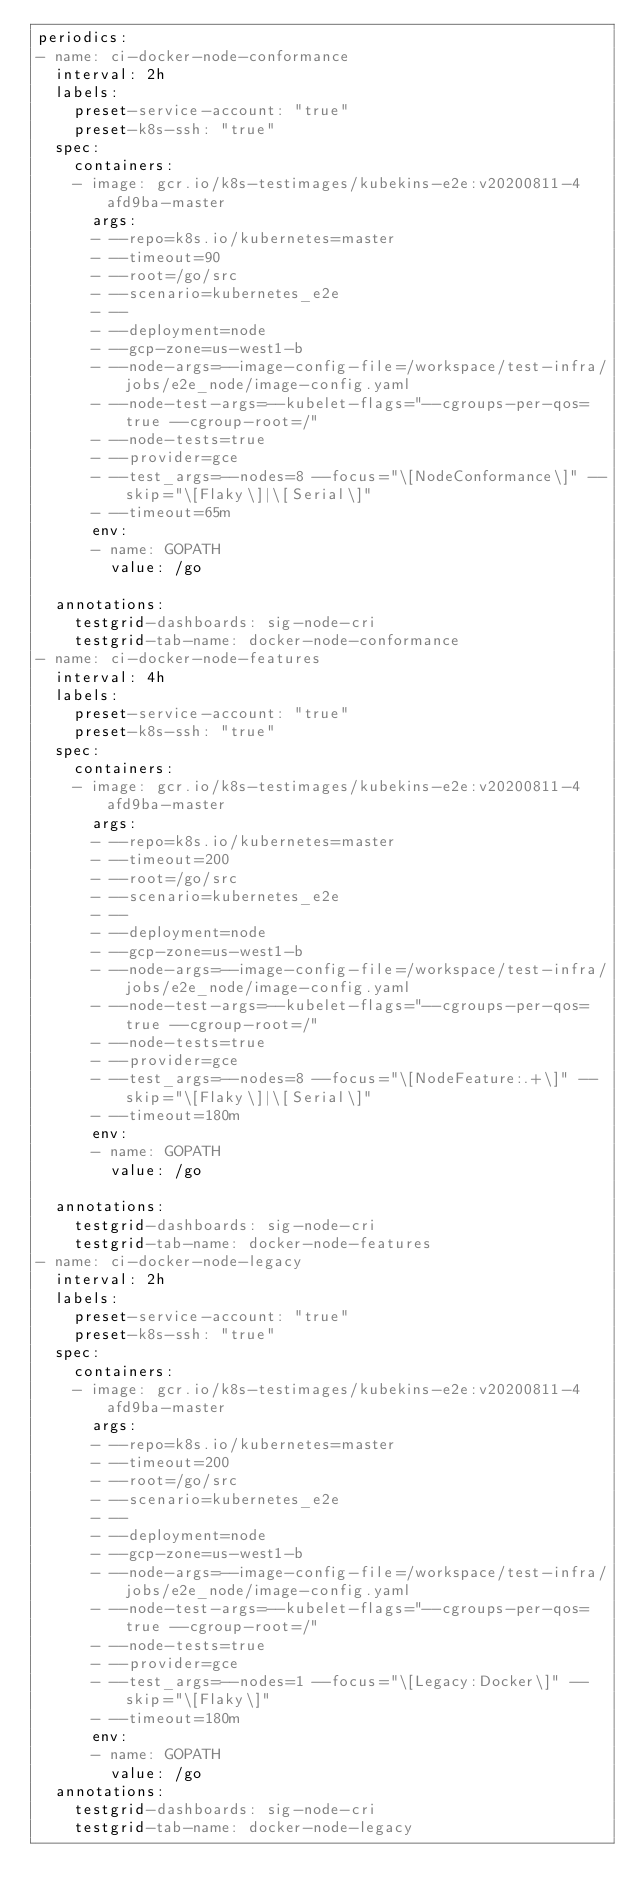<code> <loc_0><loc_0><loc_500><loc_500><_YAML_>periodics:
- name: ci-docker-node-conformance
  interval: 2h
  labels:
    preset-service-account: "true"
    preset-k8s-ssh: "true"
  spec:
    containers:
    - image: gcr.io/k8s-testimages/kubekins-e2e:v20200811-4afd9ba-master
      args:
      - --repo=k8s.io/kubernetes=master
      - --timeout=90
      - --root=/go/src
      - --scenario=kubernetes_e2e
      - --
      - --deployment=node
      - --gcp-zone=us-west1-b
      - --node-args=--image-config-file=/workspace/test-infra/jobs/e2e_node/image-config.yaml
      - --node-test-args=--kubelet-flags="--cgroups-per-qos=true --cgroup-root=/"
      - --node-tests=true
      - --provider=gce
      - --test_args=--nodes=8 --focus="\[NodeConformance\]" --skip="\[Flaky\]|\[Serial\]"
      - --timeout=65m
      env:
      - name: GOPATH
        value: /go

  annotations:
    testgrid-dashboards: sig-node-cri
    testgrid-tab-name: docker-node-conformance
- name: ci-docker-node-features
  interval: 4h
  labels:
    preset-service-account: "true"
    preset-k8s-ssh: "true"
  spec:
    containers:
    - image: gcr.io/k8s-testimages/kubekins-e2e:v20200811-4afd9ba-master
      args:
      - --repo=k8s.io/kubernetes=master
      - --timeout=200
      - --root=/go/src
      - --scenario=kubernetes_e2e
      - --
      - --deployment=node
      - --gcp-zone=us-west1-b
      - --node-args=--image-config-file=/workspace/test-infra/jobs/e2e_node/image-config.yaml
      - --node-test-args=--kubelet-flags="--cgroups-per-qos=true --cgroup-root=/"
      - --node-tests=true
      - --provider=gce
      - --test_args=--nodes=8 --focus="\[NodeFeature:.+\]" --skip="\[Flaky\]|\[Serial\]"
      - --timeout=180m
      env:
      - name: GOPATH
        value: /go

  annotations:
    testgrid-dashboards: sig-node-cri
    testgrid-tab-name: docker-node-features
- name: ci-docker-node-legacy
  interval: 2h
  labels:
    preset-service-account: "true"
    preset-k8s-ssh: "true"
  spec:
    containers:
    - image: gcr.io/k8s-testimages/kubekins-e2e:v20200811-4afd9ba-master
      args:
      - --repo=k8s.io/kubernetes=master
      - --timeout=200
      - --root=/go/src
      - --scenario=kubernetes_e2e
      - --
      - --deployment=node
      - --gcp-zone=us-west1-b
      - --node-args=--image-config-file=/workspace/test-infra/jobs/e2e_node/image-config.yaml
      - --node-test-args=--kubelet-flags="--cgroups-per-qos=true --cgroup-root=/"
      - --node-tests=true
      - --provider=gce
      - --test_args=--nodes=1 --focus="\[Legacy:Docker\]" --skip="\[Flaky\]"
      - --timeout=180m
      env:
      - name: GOPATH
        value: /go
  annotations:
    testgrid-dashboards: sig-node-cri
    testgrid-tab-name: docker-node-legacy
</code> 